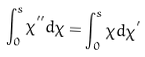Convert formula to latex. <formula><loc_0><loc_0><loc_500><loc_500>\int _ { 0 } ^ { s } \chi ^ { ^ { \prime \prime } } d \chi = \int _ { 0 } ^ { s } \chi d \chi ^ { ^ { \prime } }</formula> 